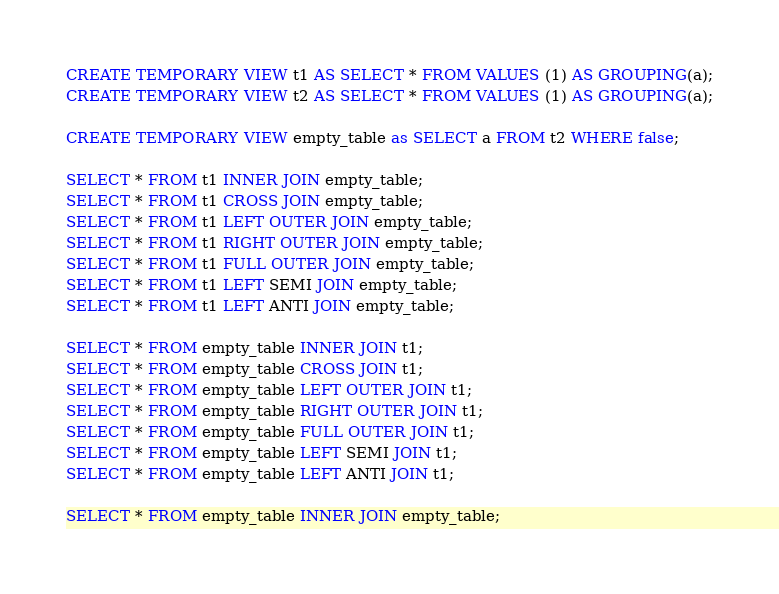Convert code to text. <code><loc_0><loc_0><loc_500><loc_500><_SQL_>CREATE TEMPORARY VIEW t1 AS SELECT * FROM VALUES (1) AS GROUPING(a);
CREATE TEMPORARY VIEW t2 AS SELECT * FROM VALUES (1) AS GROUPING(a);

CREATE TEMPORARY VIEW empty_table as SELECT a FROM t2 WHERE false;

SELECT * FROM t1 INNER JOIN empty_table;
SELECT * FROM t1 CROSS JOIN empty_table;
SELECT * FROM t1 LEFT OUTER JOIN empty_table;
SELECT * FROM t1 RIGHT OUTER JOIN empty_table;
SELECT * FROM t1 FULL OUTER JOIN empty_table;
SELECT * FROM t1 LEFT SEMI JOIN empty_table;
SELECT * FROM t1 LEFT ANTI JOIN empty_table;

SELECT * FROM empty_table INNER JOIN t1;
SELECT * FROM empty_table CROSS JOIN t1;
SELECT * FROM empty_table LEFT OUTER JOIN t1;
SELECT * FROM empty_table RIGHT OUTER JOIN t1;
SELECT * FROM empty_table FULL OUTER JOIN t1;
SELECT * FROM empty_table LEFT SEMI JOIN t1;
SELECT * FROM empty_table LEFT ANTI JOIN t1;

SELECT * FROM empty_table INNER JOIN empty_table;</code> 